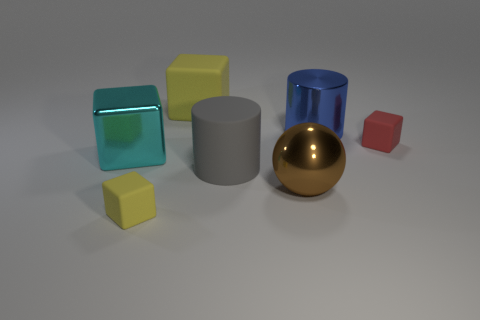There is a tiny yellow thing that is the same shape as the big yellow matte thing; what is its material?
Give a very brief answer. Rubber. What number of other objects are there of the same size as the red matte block?
Provide a succinct answer. 1. What material is the blue thing?
Offer a terse response. Metal. Are there more large cylinders on the right side of the large yellow object than big yellow blocks?
Give a very brief answer. Yes. Are there any gray matte things?
Ensure brevity in your answer.  Yes. How many other things are there of the same shape as the gray matte object?
Make the answer very short. 1. There is a small thing left of the blue metal cylinder; does it have the same color as the tiny rubber object right of the large metallic ball?
Provide a short and direct response. No. What size is the cyan thing left of the tiny block that is behind the large metallic object that is on the left side of the big matte cube?
Your answer should be very brief. Large. What shape is the large thing that is both left of the brown ball and in front of the cyan object?
Offer a terse response. Cylinder. Are there the same number of objects that are in front of the cyan block and small rubber cubes that are in front of the gray object?
Offer a very short reply. No. 